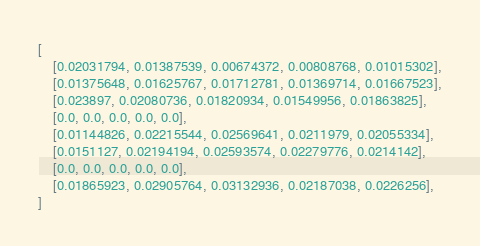Convert code to text. <code><loc_0><loc_0><loc_500><loc_500><_Python_>[
    [0.02031794, 0.01387539, 0.00674372, 0.00808768, 0.01015302],
    [0.01375648, 0.01625767, 0.01712781, 0.01369714, 0.01667523],
    [0.023897, 0.02080736, 0.01820934, 0.01549956, 0.01863825],
    [0.0, 0.0, 0.0, 0.0, 0.0],
    [0.01144826, 0.02215544, 0.02569641, 0.0211979, 0.02055334],
    [0.0151127, 0.02194194, 0.02593574, 0.02279776, 0.0214142],
    [0.0, 0.0, 0.0, 0.0, 0.0],
    [0.01865923, 0.02905764, 0.03132936, 0.02187038, 0.0226256],
]
</code> 